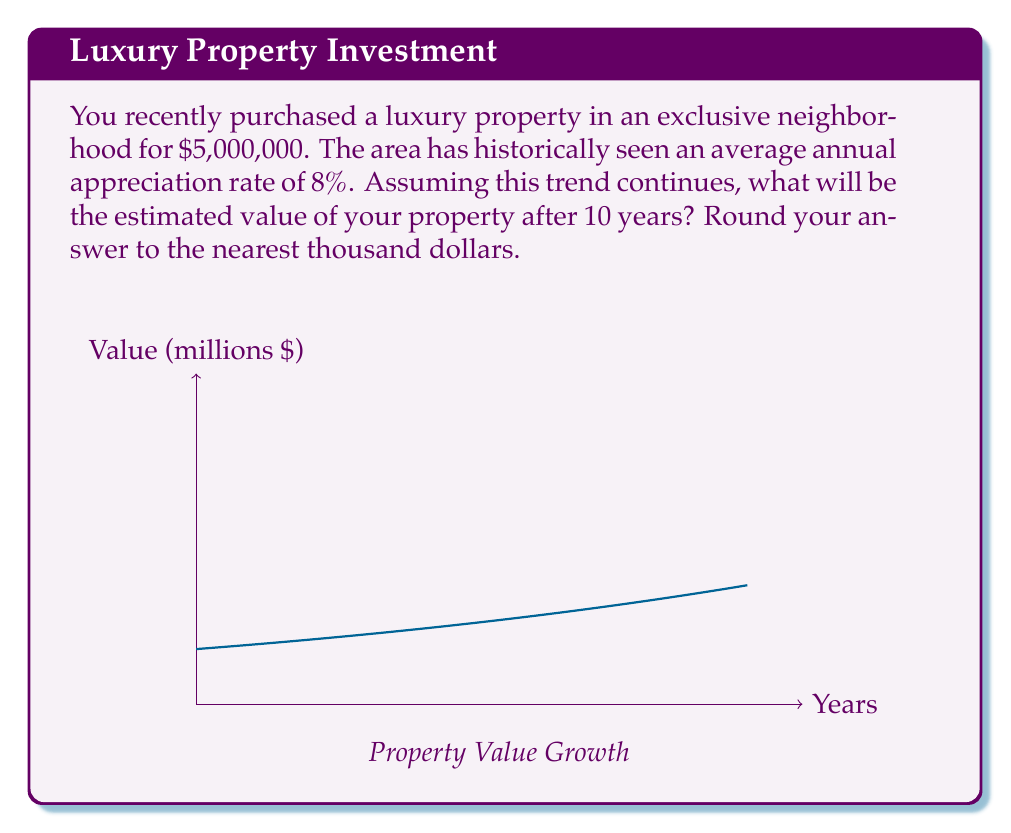Provide a solution to this math problem. Let's approach this step-by-step:

1) The initial value of the property is $5,000,000.

2) The annual appreciation rate is 8%, which means the value increases by a factor of 1.08 each year.

3) We need to calculate the value after 10 years.

4) This scenario follows the compound interest formula:
   $$A = P(1 + r)^n$$
   Where:
   $A$ = Final amount
   $P$ = Principal (initial investment)
   $r$ = Annual rate (as a decimal)
   $n$ = Number of years

5) Plugging in our values:
   $$A = 5,000,000(1 + 0.08)^{10}$$

6) Calculate:
   $$A = 5,000,000(1.08)^{10}$$
   $$A = 5,000,000(2.1589)$$
   $$A = 10,794,500$$

7) Rounding to the nearest thousand:
   $$A \approx 10,795,000$$
Answer: $10,795,000 